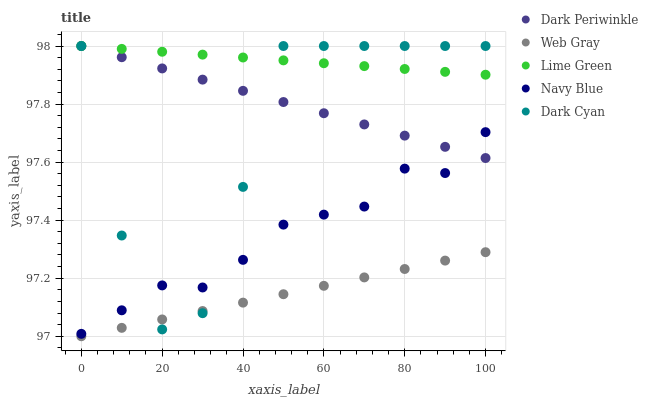Does Web Gray have the minimum area under the curve?
Answer yes or no. Yes. Does Lime Green have the maximum area under the curve?
Answer yes or no. Yes. Does Navy Blue have the minimum area under the curve?
Answer yes or no. No. Does Navy Blue have the maximum area under the curve?
Answer yes or no. No. Is Web Gray the smoothest?
Answer yes or no. Yes. Is Dark Cyan the roughest?
Answer yes or no. Yes. Is Navy Blue the smoothest?
Answer yes or no. No. Is Navy Blue the roughest?
Answer yes or no. No. Does Web Gray have the lowest value?
Answer yes or no. Yes. Does Navy Blue have the lowest value?
Answer yes or no. No. Does Dark Periwinkle have the highest value?
Answer yes or no. Yes. Does Navy Blue have the highest value?
Answer yes or no. No. Is Navy Blue less than Lime Green?
Answer yes or no. Yes. Is Dark Periwinkle greater than Web Gray?
Answer yes or no. Yes. Does Dark Cyan intersect Navy Blue?
Answer yes or no. Yes. Is Dark Cyan less than Navy Blue?
Answer yes or no. No. Is Dark Cyan greater than Navy Blue?
Answer yes or no. No. Does Navy Blue intersect Lime Green?
Answer yes or no. No. 